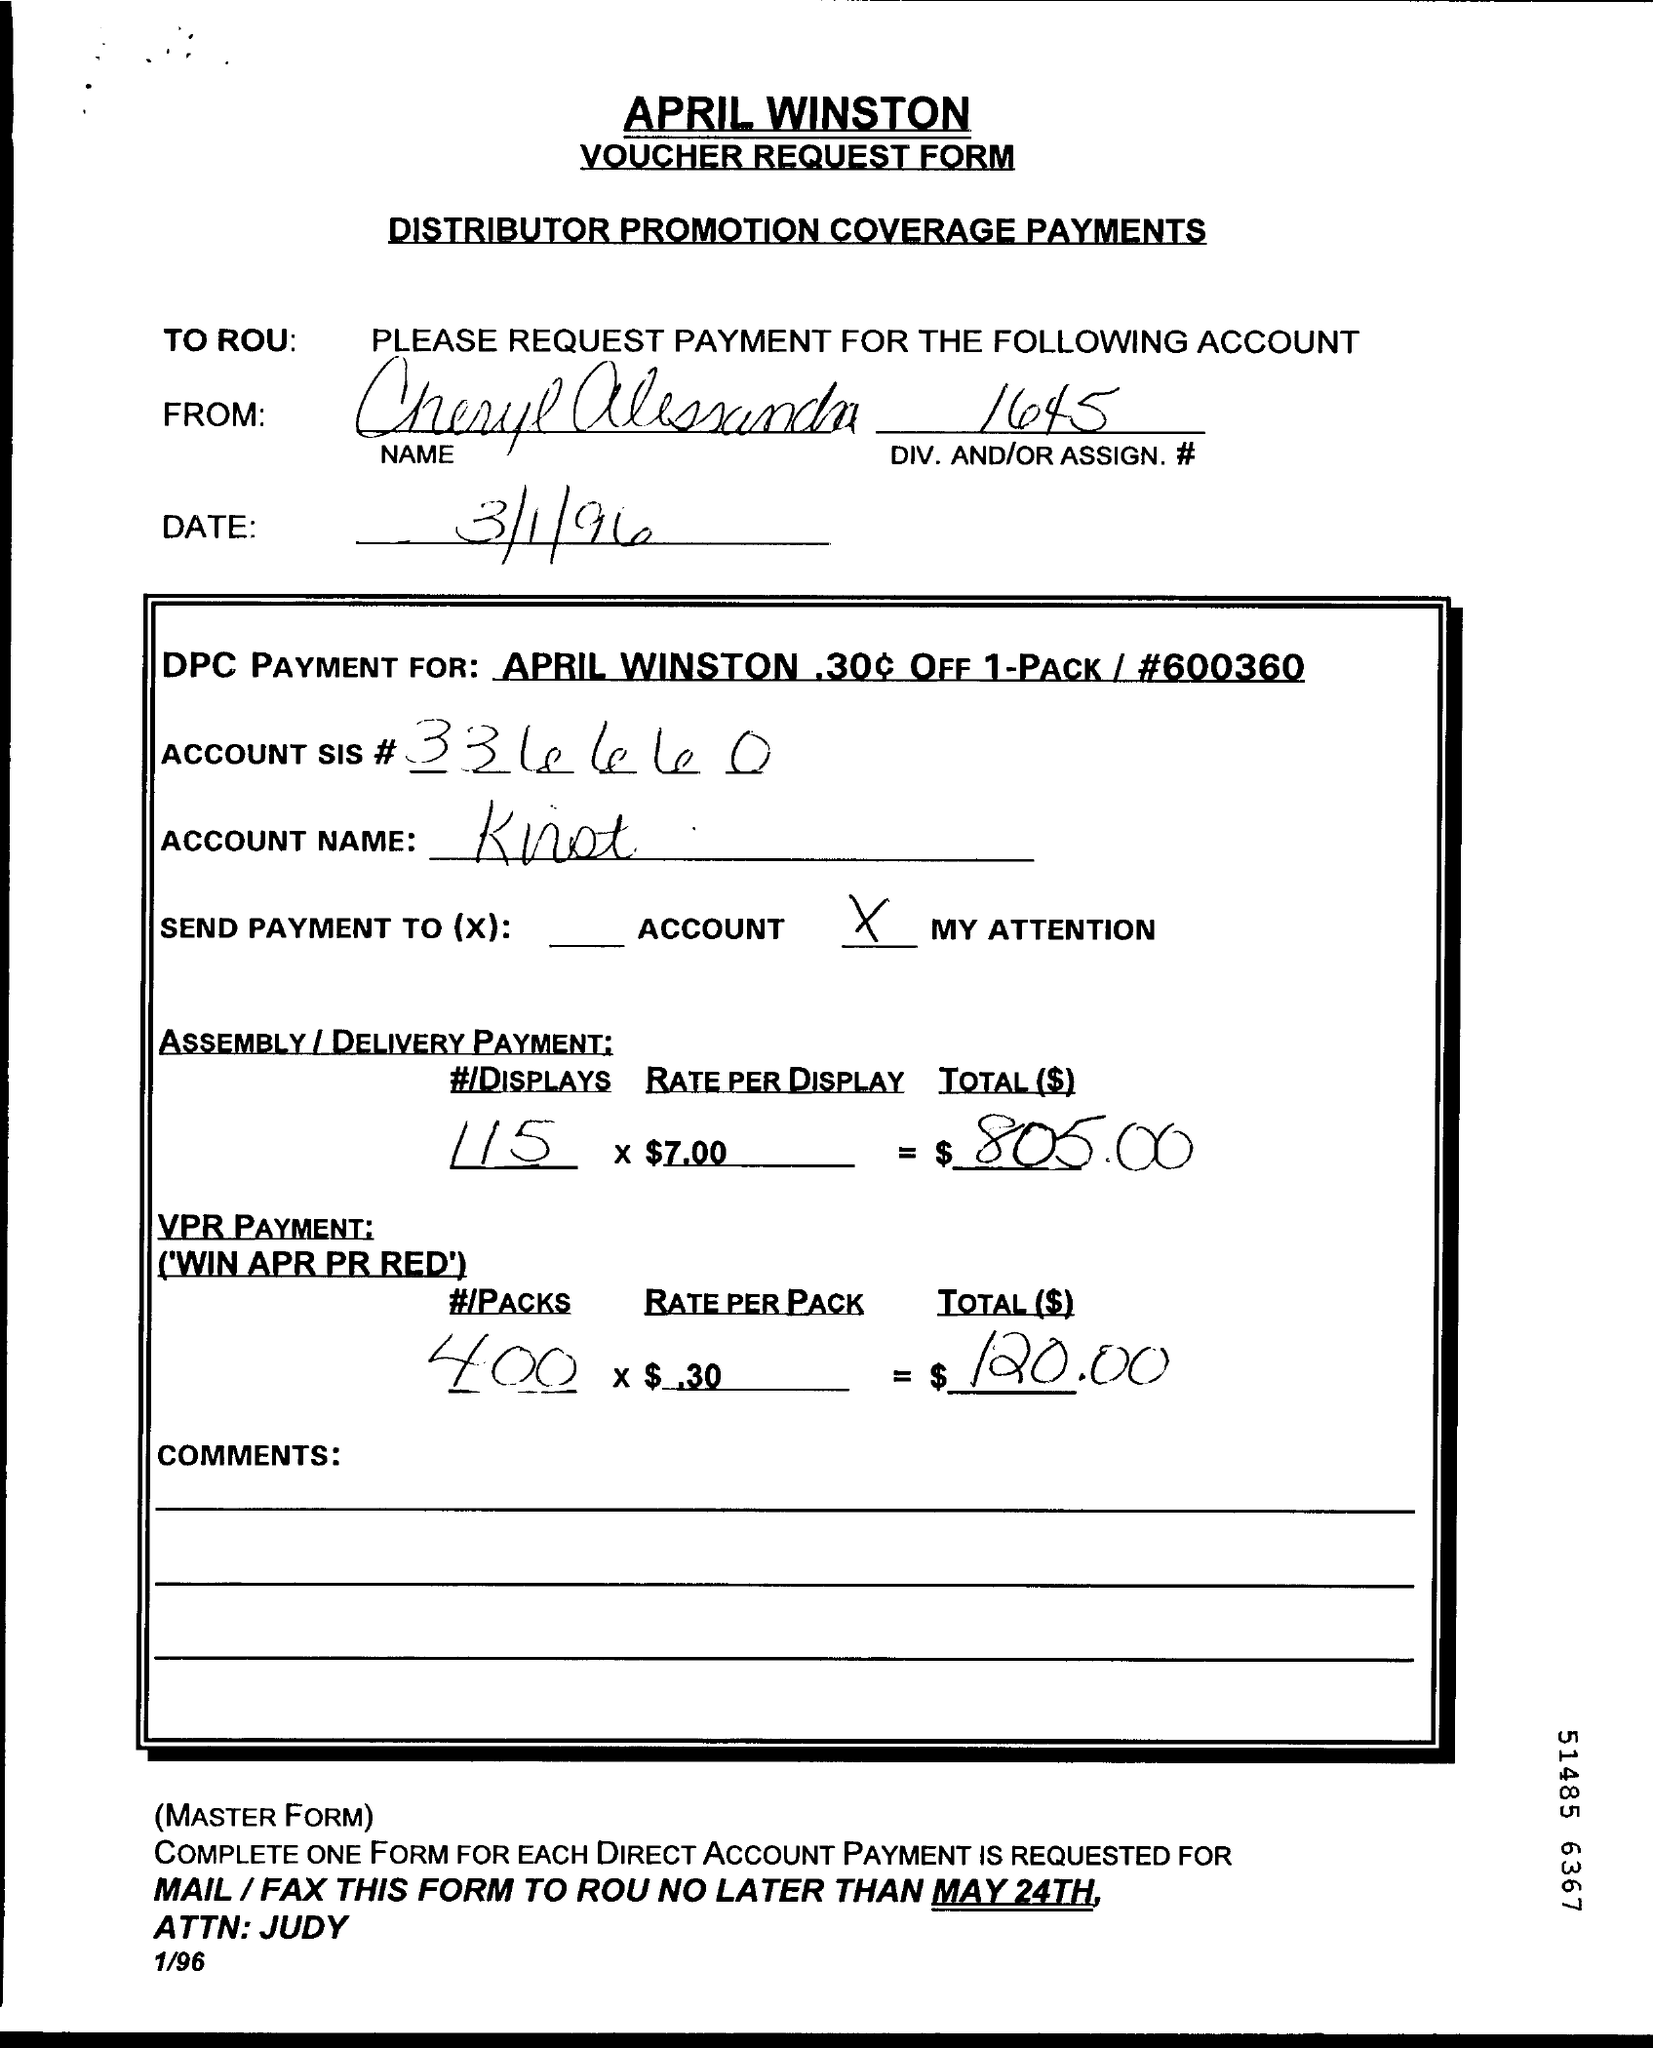Point out several critical features in this image. The DIV.AND/OR ASSIGN Number is 1645. The memorandum was dated on March 1, 1996. 